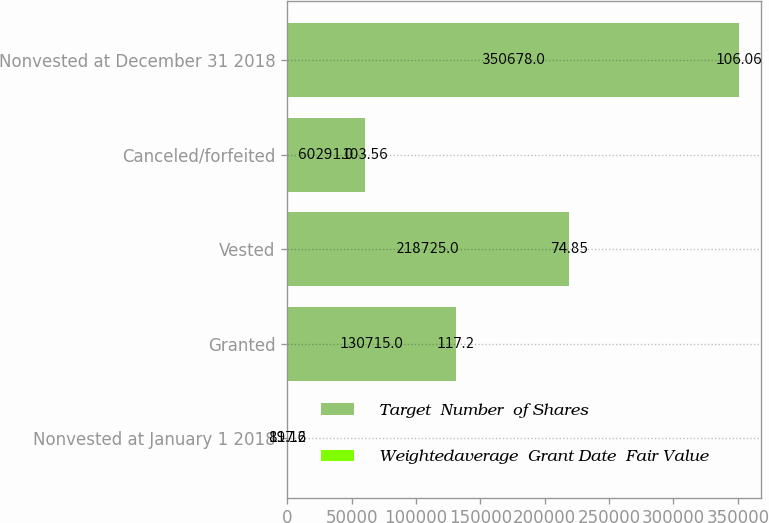<chart> <loc_0><loc_0><loc_500><loc_500><stacked_bar_chart><ecel><fcel>Nonvested at January 1 2018<fcel>Granted<fcel>Vested<fcel>Canceled/forfeited<fcel>Nonvested at December 31 2018<nl><fcel>Target  Number  of Shares<fcel>117.2<fcel>130715<fcel>218725<fcel>60291<fcel>350678<nl><fcel>Weightedaverage  Grant Date  Fair Value<fcel>89.16<fcel>117.2<fcel>74.85<fcel>103.56<fcel>106.06<nl></chart> 